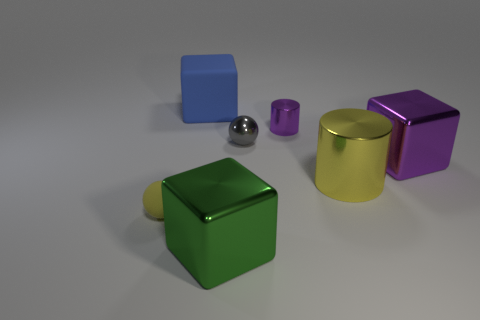There is a small thing that is the same shape as the large yellow thing; what color is it?
Offer a terse response. Purple. What shape is the small purple metal object?
Ensure brevity in your answer.  Cylinder. How many objects are big metallic cylinders or shiny cubes?
Your answer should be very brief. 3. There is a matte thing in front of the large blue rubber cube; does it have the same color as the big block behind the small gray metallic object?
Give a very brief answer. No. What number of other objects are the same shape as the large purple object?
Make the answer very short. 2. Are there any small purple matte cylinders?
Provide a short and direct response. No. How many objects are either big brown cylinders or large things behind the large metal cylinder?
Provide a short and direct response. 2. Is the size of the metal thing that is in front of the yellow matte ball the same as the blue matte object?
Your response must be concise. Yes. How many other objects are the same size as the gray metal sphere?
Provide a short and direct response. 2. What is the color of the big rubber thing?
Your answer should be very brief. Blue. 